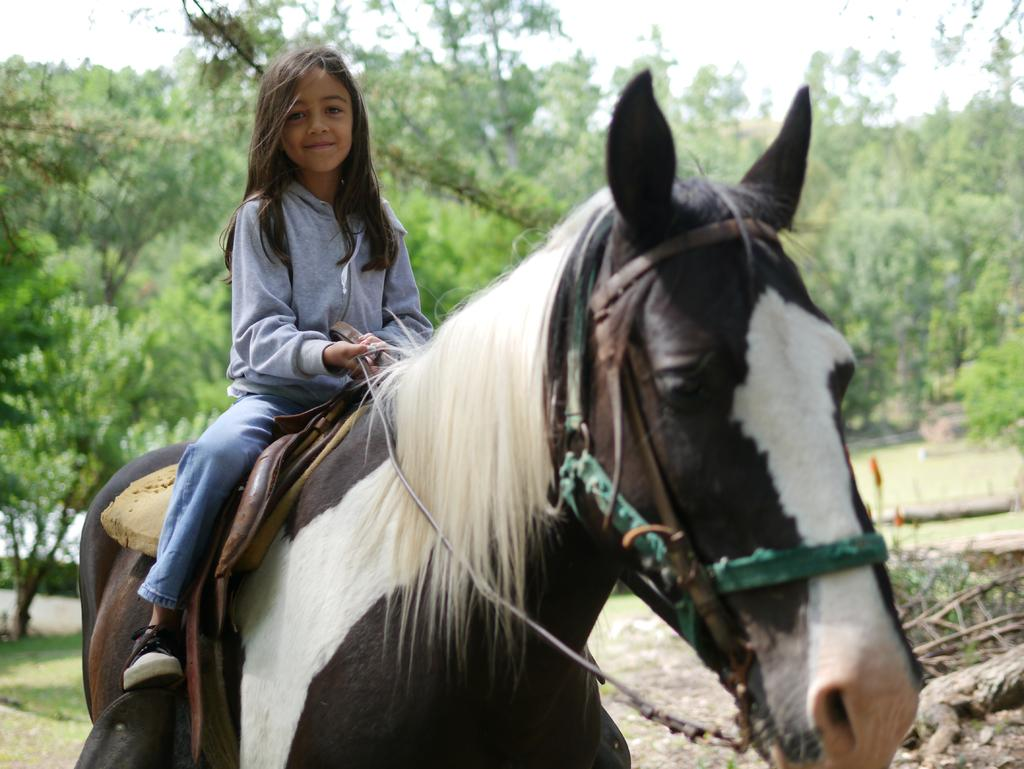Who is the main subject in the image? There is a girl in the image. What is the girl doing in the image? The girl is seated on a horse. What can be seen in the background of the image? There are trees in the background of the image. Where is the nearest airport to the girl in the image? The image does not provide any information about the location of an airport, so it cannot be determined from the image. 